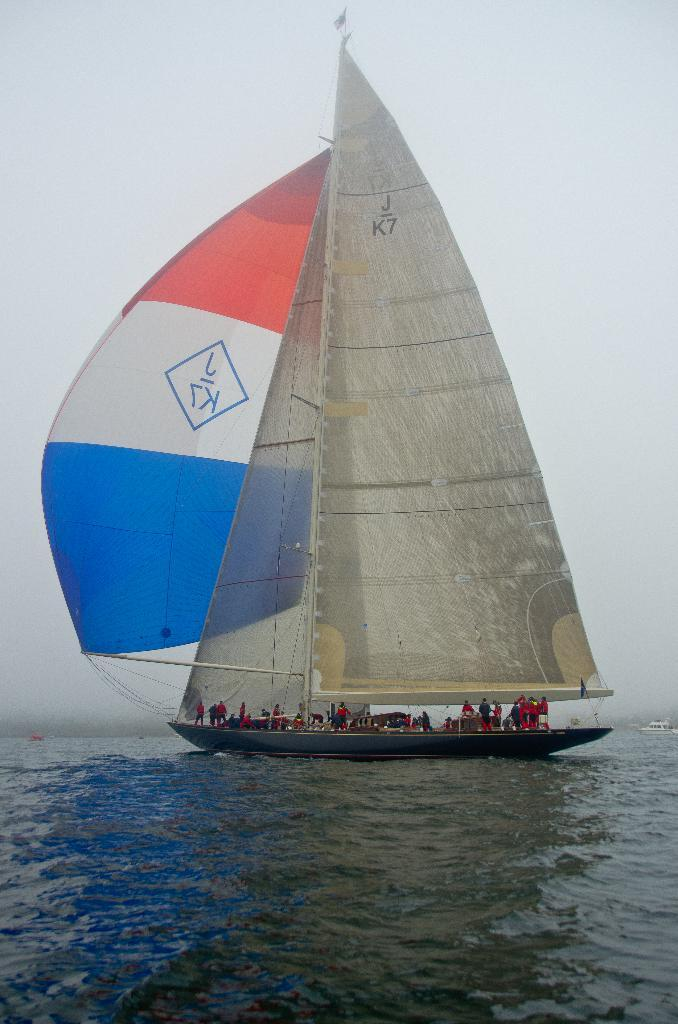What activity are the people in the image engaged in? The people in the image are sailing a boat. Where is the boat located? The boat is on the water. What are some of the equipment visible in the image? There are rods and ropes visible in the image. What can be seen in the background of the image? The sky is visible in the background of the image. Can you see any quicksand in the image? There is no quicksand present in the image. What type of bird is perched on the mast of the boat in the image? There are no birds visible in the image, let alone perched on the mast of the boat. 